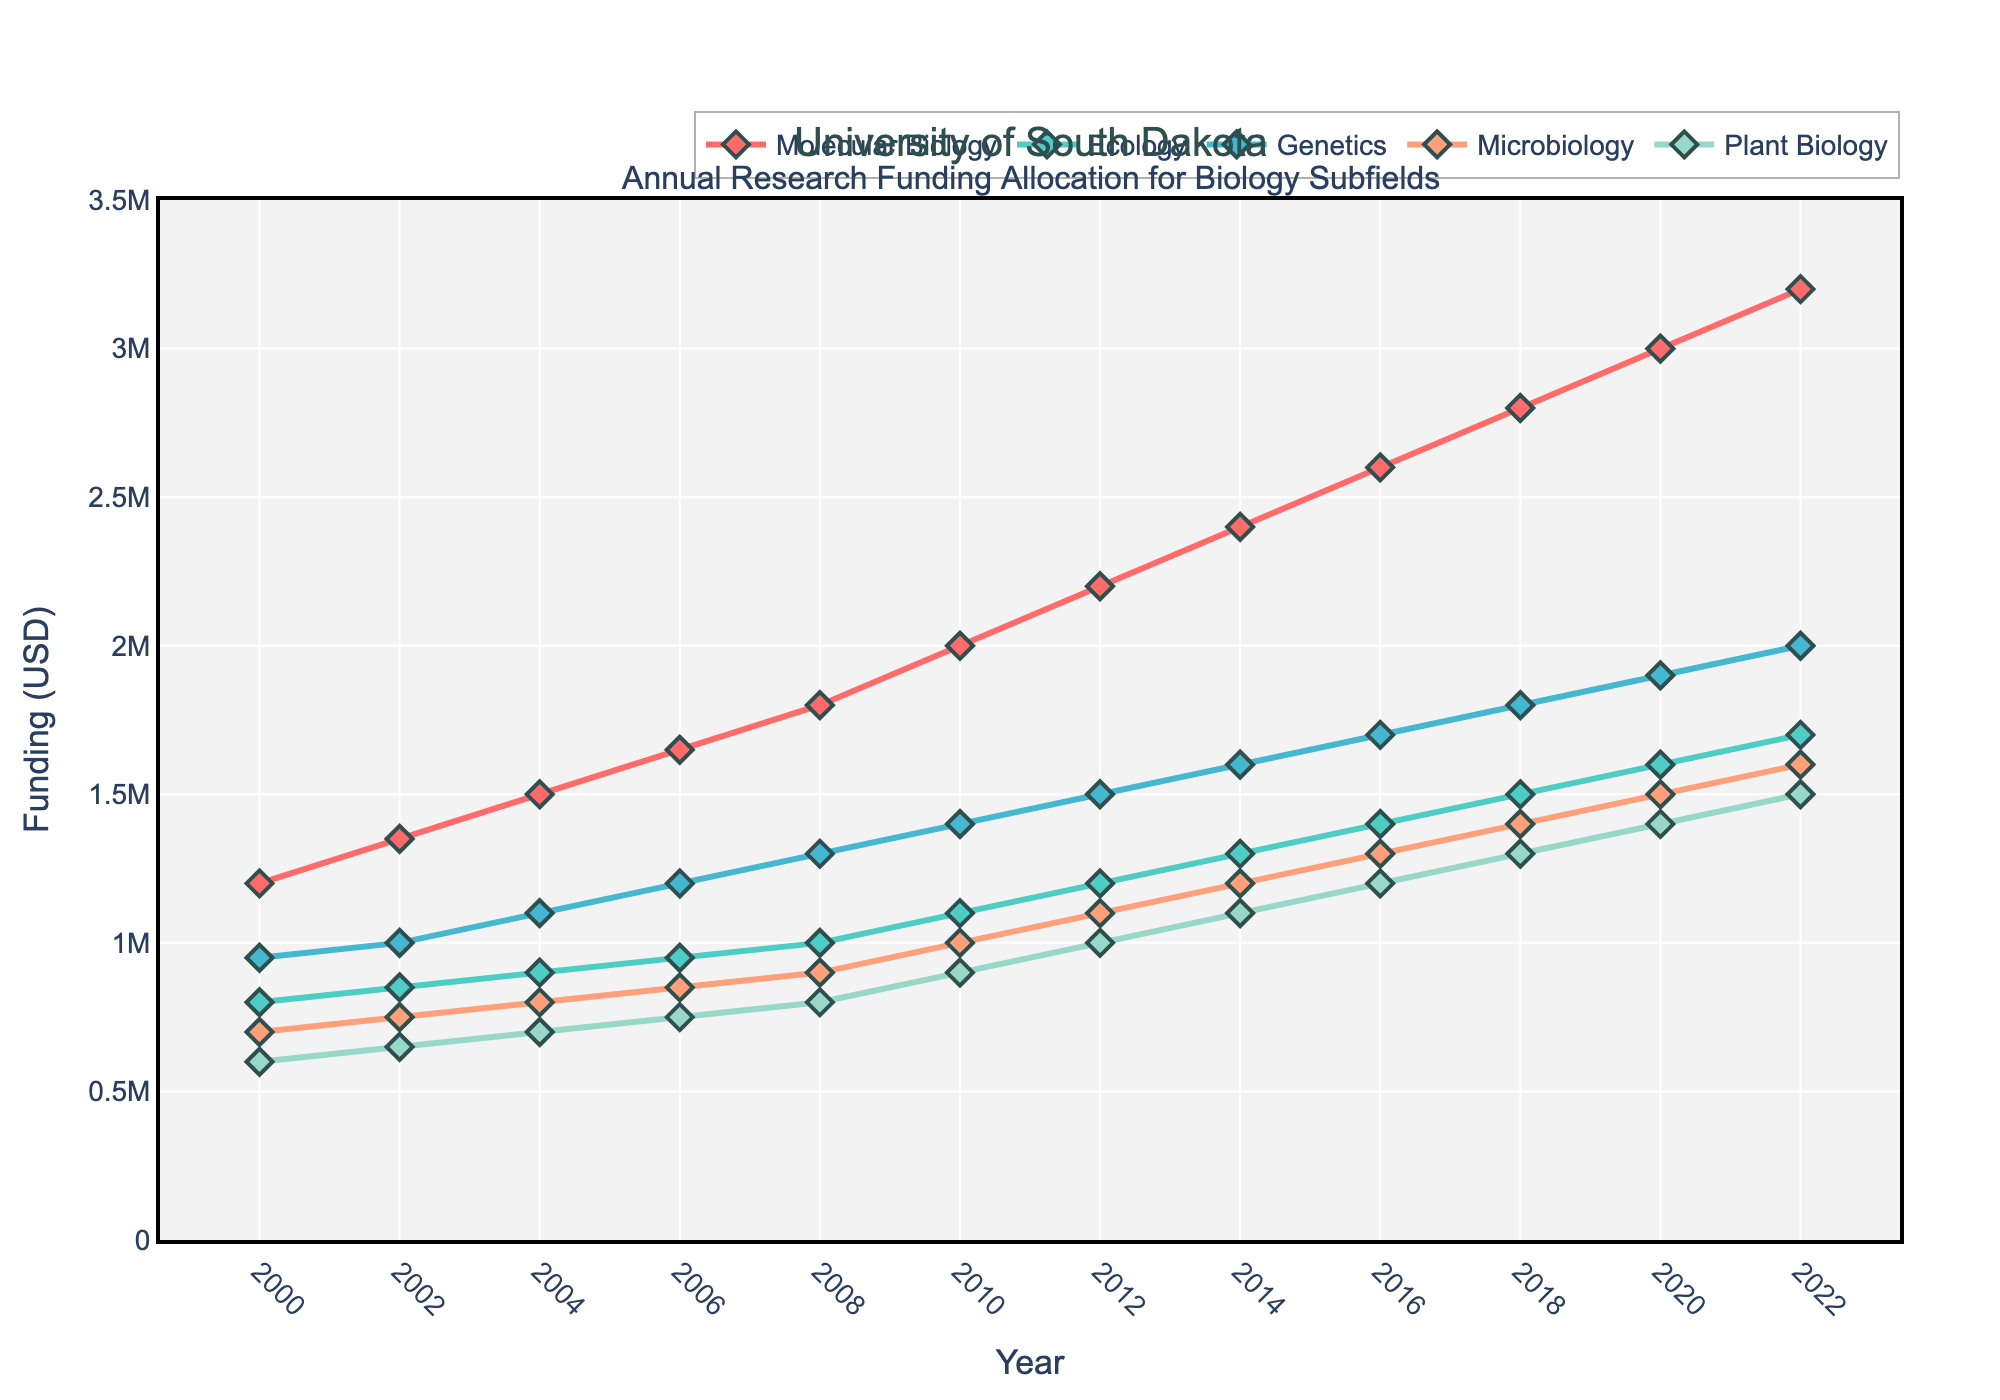What's the funding allocation for Molecular Biology in 2004? Look at the line representing Molecular Biology and locate the point at the year 2004. The value is shown as 1,500,000 USD.
Answer: 1,500,000 USD Which biology subfield had the highest funding allocation in 2016? Compare the heights of the lines at the year 2016. Molecular Biology is the highest among the subfields, showing the highest funding.
Answer: Molecular Biology What is the combined funding for Ecology and Genetics in 2012? Determine the funding amounts for Ecology and Genetics in 2012: Ecology is 1,200,000 USD and Genetics is 1,500,000 USD. Summing these amounts: 1,200,000 + 1,500,000 = 2,700,000 USD.
Answer: 2,700,000 USD How does the funding for Plant Biology in 2020 compare to its funding in 2010? Find the funding for Plant Biology in both 2020 and 2010. For 2020, it is 1,400,000 USD, and for 2010, it is 900,000 USD. Subtract the 2010 value from the 2020 value: 1,400,000 - 900,000 = 500,000 USD increase.
Answer: 500,000 USD increase What is the trend in funding for Microbiology from 2008 to 2022? Observe the trend of the line representing Microbiology from 2008 (900,000 USD) to 2022 (1,600,000 USD). Funding shows a continuous increase each observed year.
Answer: Continuous increase Which subfield saw the smallest increase in funding from 2000 to 2022? Calculate the differences in funding from 2000 to 2022 for each subfield: 
- Molecular Biology: 3,200,000 - 1,200,000 = 2,000,000
- Ecology: 1,700,000 - 800,000 = 900,000
- Genetics: 2,000,000 - 950,000 = 1,050,000
- Microbiology: 1,600,000 - 700,000 = 900,000
- Plant Biology: 1,500,000 - 600,000 = 900,000
Ecology, Microbiology, and Plant Biology have the smallest increase, all being 900,000 USD.
Answer: Ecology, Microbiology, and Plant Biology What funding trend differences can be observed between Molecular Biology and Genetics between 2000 and 2012? Compare the trends of Molecular Biology and Genetics from 2000 to 2012. Molecular Biology shows a steady increase from 1,200,000 to 2,200,000 USD. Genetics also increases steadily but at a slower rate, from 950,000 to 1,500,000 USD. The gradient of increase is greater for Molecular Biology.
Answer: Molecular Biology shows a steeper increase How much was the total funding for all subfields combined in 2022? Add the funding amounts for each subfield in 2022: 
3,200,000 (Molecular Biology) + 1,700,000 (Ecology) + 2,000,000 (Genetics) + 1,600,000 (Microbiology) + 1,500,000 (Plant Biology) = 10,000,000 USD.
Answer: 10,000,000 USD What is the average annual increase in funding for Molecular Biology from 2000 to 2022? Find the total increase in funding for Molecular Biology: 3,200,000 (2022) - 1,200,000 (2000) = 2,000,000 USD. Count the number of interval years: 2022 - 2000 = 22 years. Calculate the average annual increase: 2,000,000 / 22 ≈ 90,909 USD/year.
Answer: 90,909 USD/year Which subfield had consistent growth without any declines from 2000 to 2022? Observe each subfield's line from 2000 to 2022 for consistency without any downward trends. Molecular Biology's line shows consistent growth throughout the period.
Answer: Molecular Biology 